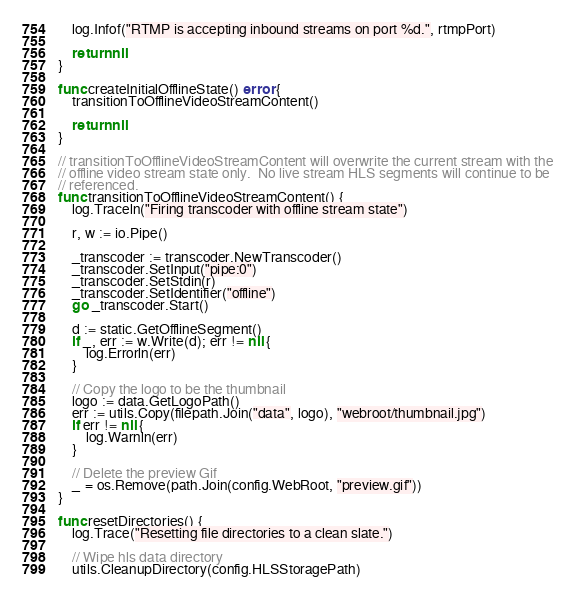Convert code to text. <code><loc_0><loc_0><loc_500><loc_500><_Go_>	log.Infof("RTMP is accepting inbound streams on port %d.", rtmpPort)

	return nil
}

func createInitialOfflineState() error {
	transitionToOfflineVideoStreamContent()

	return nil
}

// transitionToOfflineVideoStreamContent will overwrite the current stream with the
// offline video stream state only.  No live stream HLS segments will continue to be
// referenced.
func transitionToOfflineVideoStreamContent() {
	log.Traceln("Firing transcoder with offline stream state")

	r, w := io.Pipe()

	_transcoder := transcoder.NewTranscoder()
	_transcoder.SetInput("pipe:0")
	_transcoder.SetStdin(r)
	_transcoder.SetIdentifier("offline")
	go _transcoder.Start()

	d := static.GetOfflineSegment()
	if _, err := w.Write(d); err != nil {
		log.Errorln(err)
	}

	// Copy the logo to be the thumbnail
	logo := data.GetLogoPath()
	err := utils.Copy(filepath.Join("data", logo), "webroot/thumbnail.jpg")
	if err != nil {
		log.Warnln(err)
	}

	// Delete the preview Gif
	_ = os.Remove(path.Join(config.WebRoot, "preview.gif"))
}

func resetDirectories() {
	log.Trace("Resetting file directories to a clean slate.")

	// Wipe hls data directory
	utils.CleanupDirectory(config.HLSStoragePath)
</code> 